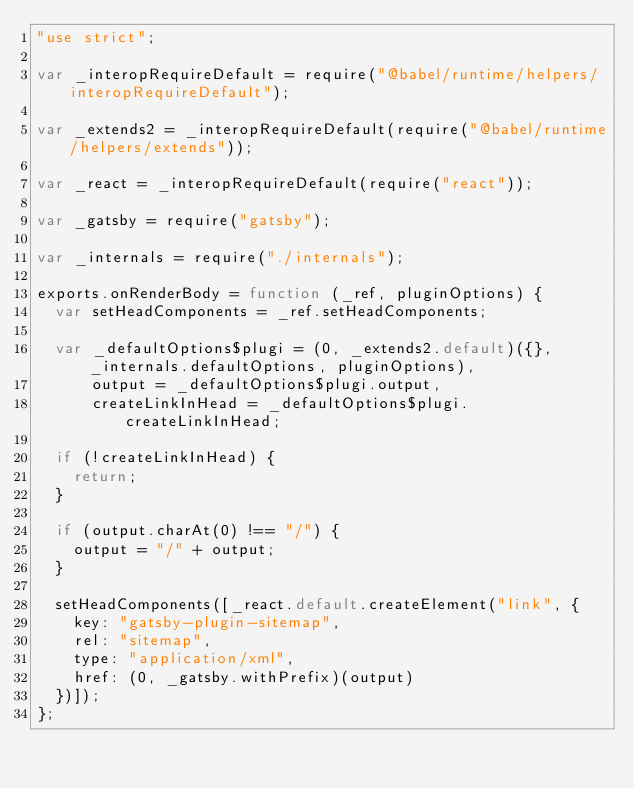<code> <loc_0><loc_0><loc_500><loc_500><_JavaScript_>"use strict";

var _interopRequireDefault = require("@babel/runtime/helpers/interopRequireDefault");

var _extends2 = _interopRequireDefault(require("@babel/runtime/helpers/extends"));

var _react = _interopRequireDefault(require("react"));

var _gatsby = require("gatsby");

var _internals = require("./internals");

exports.onRenderBody = function (_ref, pluginOptions) {
  var setHeadComponents = _ref.setHeadComponents;

  var _defaultOptions$plugi = (0, _extends2.default)({}, _internals.defaultOptions, pluginOptions),
      output = _defaultOptions$plugi.output,
      createLinkInHead = _defaultOptions$plugi.createLinkInHead;

  if (!createLinkInHead) {
    return;
  }

  if (output.charAt(0) !== "/") {
    output = "/" + output;
  }

  setHeadComponents([_react.default.createElement("link", {
    key: "gatsby-plugin-sitemap",
    rel: "sitemap",
    type: "application/xml",
    href: (0, _gatsby.withPrefix)(output)
  })]);
};</code> 